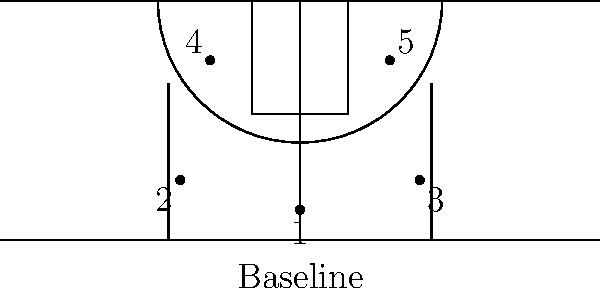In the given diagram of a basketball court with player positions marked, which offensive play setup is most likely being illustrated, and how could it be optimized for a pick-and-roll play involving players 1 and 5? To analyze this offensive setup and optimize it for a pick-and-roll play:

1. Current setup analysis:
   - Player 1 (point guard) is at the top of the key
   - Players 2 and 3 (likely wings) are spread in the corners
   - Players 4 and 5 (likely forwards/center) are at the elbows

2. This formation resembles a "5-out" or "spread" offense, which creates space for drives and cuts.

3. To optimize for a pick-and-roll with players 1 and 5:
   a) Player 5 should move up to set a screen for Player 1
   b) Player 4 should move to the weak-side corner
   c) Players 2 and 3 should maintain their positions for spacing

4. The optimized formation would look like:
   - Player 1: Top of the key (unchanged)
   - Player 5: Slightly above the top of the key, ready to screen
   - Player 4: Weak-side corner (e.g., left corner)
   - Players 2 and 3: Maintain corner positions

5. This optimization:
   - Creates space for the pick-and-roll action
   - Provides passing options if the defense collapses
   - Maintains floor spacing to prevent help defense

6. The pick-and-roll can then be executed:
   - Player 5 sets a screen for Player 1
   - Player 1 uses the screen to drive or shoot
   - Player 5 rolls to the basket
   - Other players are ready for kick-out passes

This optimized setup maximizes the effectiveness of the pick-and-roll while maintaining overall offensive spacing.
Answer: Move Player 5 to screen, Player 4 to weak-side corner; execute pick-and-roll. 